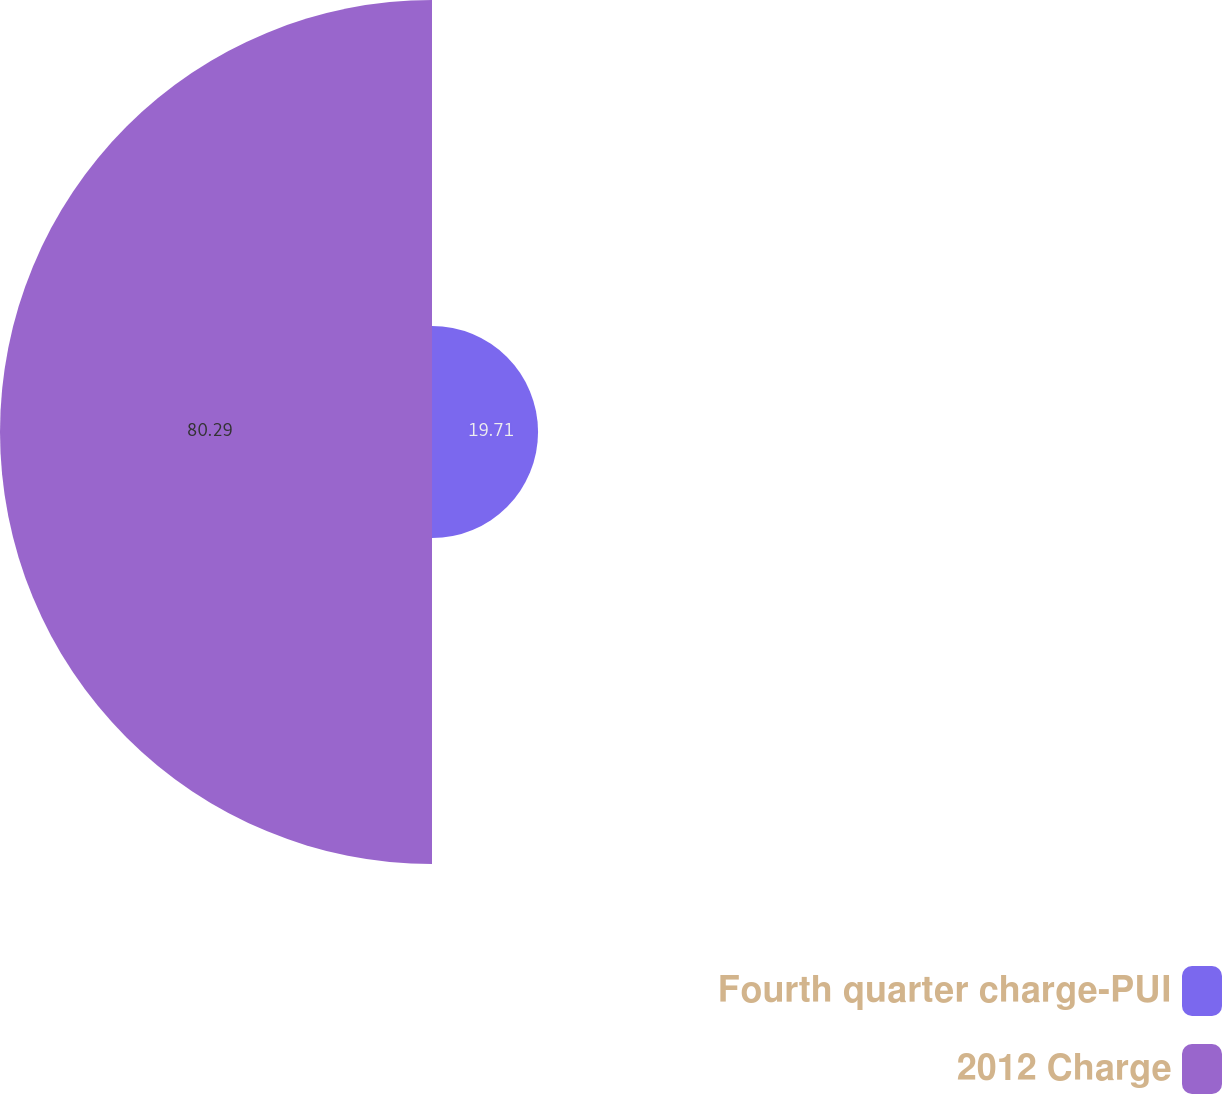Convert chart. <chart><loc_0><loc_0><loc_500><loc_500><pie_chart><fcel>Fourth quarter charge-PUI<fcel>2012 Charge<nl><fcel>19.71%<fcel>80.29%<nl></chart> 